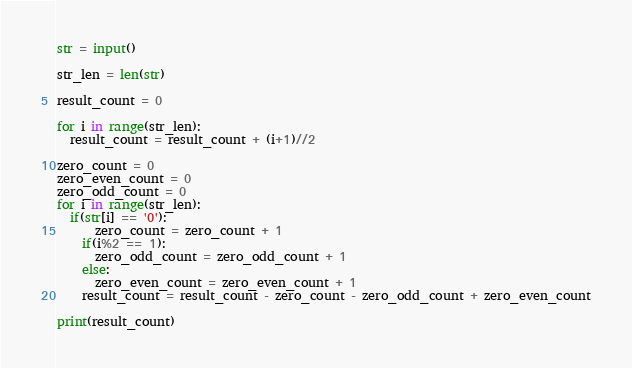<code> <loc_0><loc_0><loc_500><loc_500><_Python_>str = input()
 
str_len = len(str)
 
result_count = 0
 
for i in range(str_len):
  result_count = result_count + (i+1)//2

zero_count = 0
zero_even_count = 0
zero_odd_count = 0
for i in range(str_len):
  if(str[i] == '0'):
      zero_count = zero_count + 1
    if(i%2 == 1):
      zero_odd_count = zero_odd_count + 1
    else:
      zero_even_count = zero_even_count + 1
    result_count = result_count - zero_count - zero_odd_count + zero_even_count

print(result_count)
</code> 